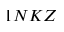<formula> <loc_0><loc_0><loc_500><loc_500>1 N K Z</formula> 